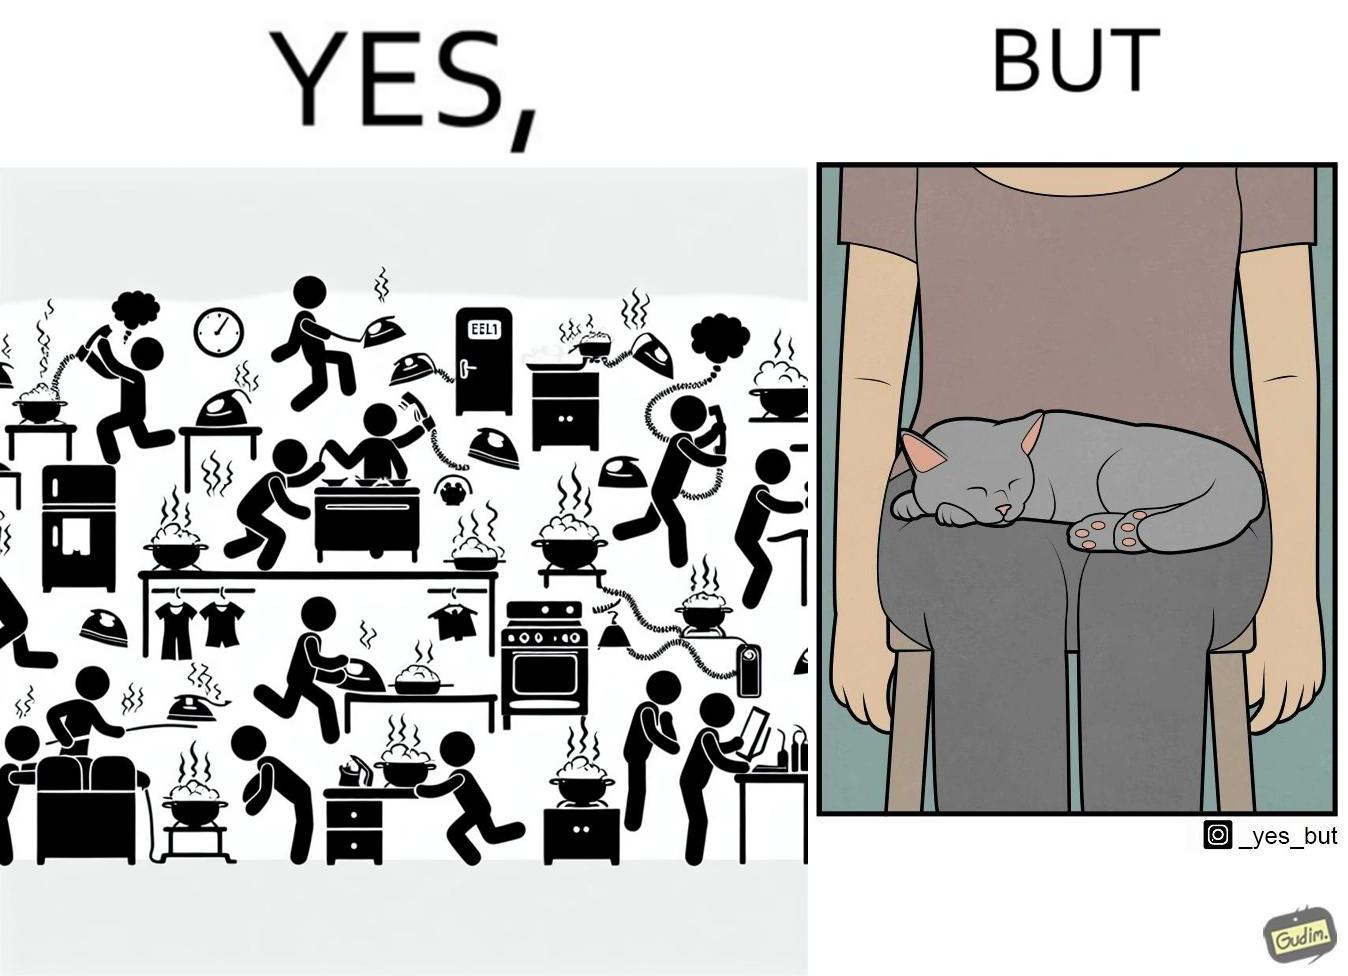Describe the satirical element in this image. the irony in this image is that people ignore all the chaos around them and get distracted by a cat. 